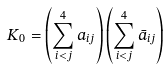<formula> <loc_0><loc_0><loc_500><loc_500>K _ { 0 } = \left ( \sum ^ { 4 } _ { i < j } a _ { i j } \right ) \left ( \sum ^ { 4 } _ { i < j } \bar { a } _ { i j } \right )</formula> 